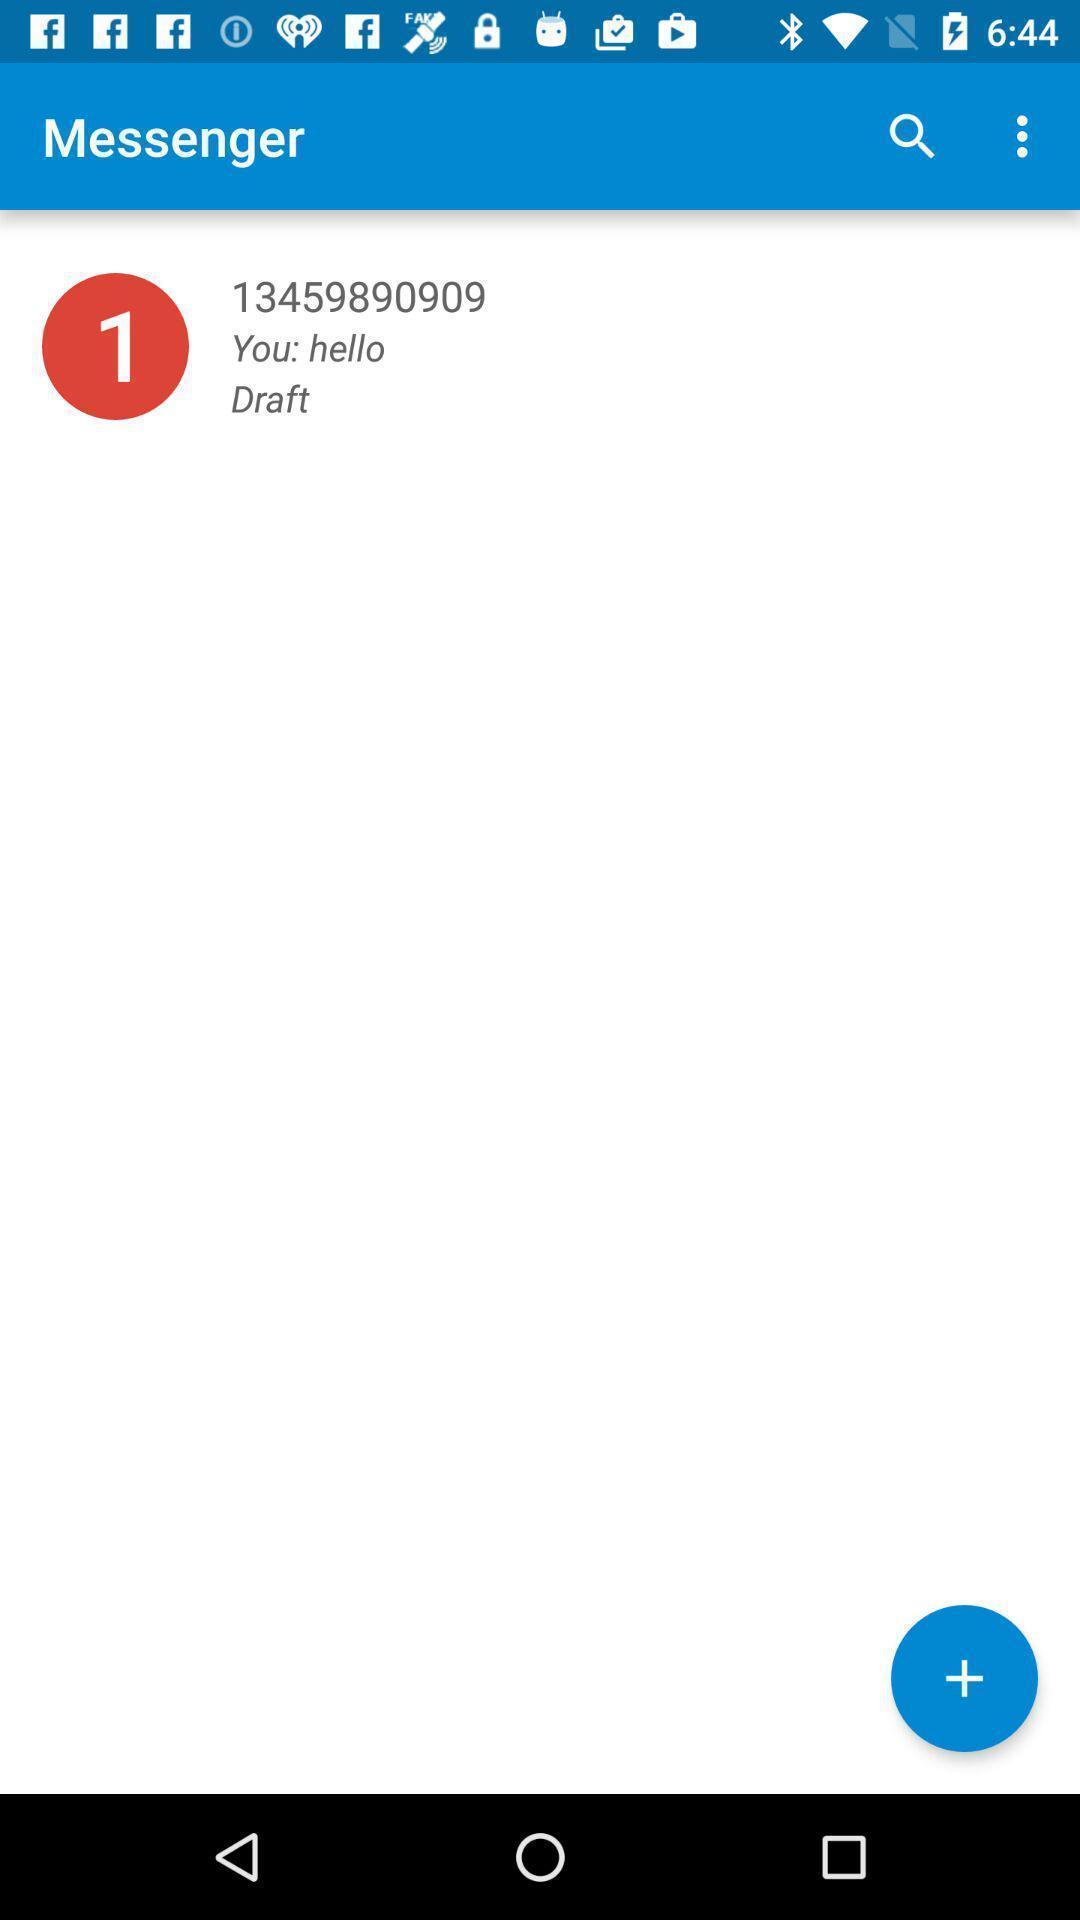What details can you identify in this image? Page of the messenger in the app. 